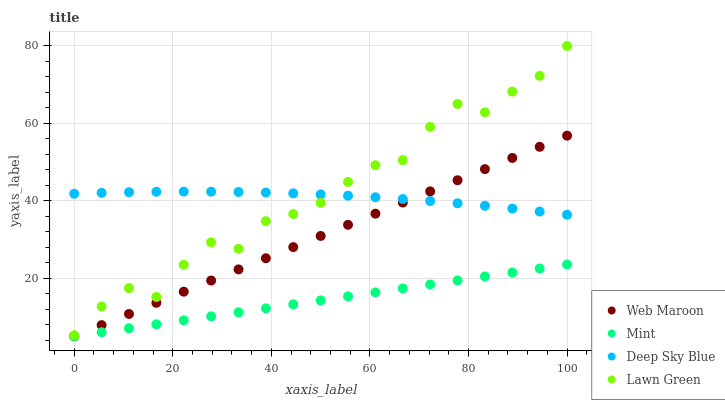Does Mint have the minimum area under the curve?
Answer yes or no. Yes. Does Lawn Green have the maximum area under the curve?
Answer yes or no. Yes. Does Web Maroon have the minimum area under the curve?
Answer yes or no. No. Does Web Maroon have the maximum area under the curve?
Answer yes or no. No. Is Mint the smoothest?
Answer yes or no. Yes. Is Lawn Green the roughest?
Answer yes or no. Yes. Is Web Maroon the smoothest?
Answer yes or no. No. Is Web Maroon the roughest?
Answer yes or no. No. Does Mint have the lowest value?
Answer yes or no. Yes. Does Deep Sky Blue have the lowest value?
Answer yes or no. No. Does Lawn Green have the highest value?
Answer yes or no. Yes. Does Web Maroon have the highest value?
Answer yes or no. No. Is Mint less than Lawn Green?
Answer yes or no. Yes. Is Lawn Green greater than Mint?
Answer yes or no. Yes. Does Web Maroon intersect Mint?
Answer yes or no. Yes. Is Web Maroon less than Mint?
Answer yes or no. No. Is Web Maroon greater than Mint?
Answer yes or no. No. Does Mint intersect Lawn Green?
Answer yes or no. No. 